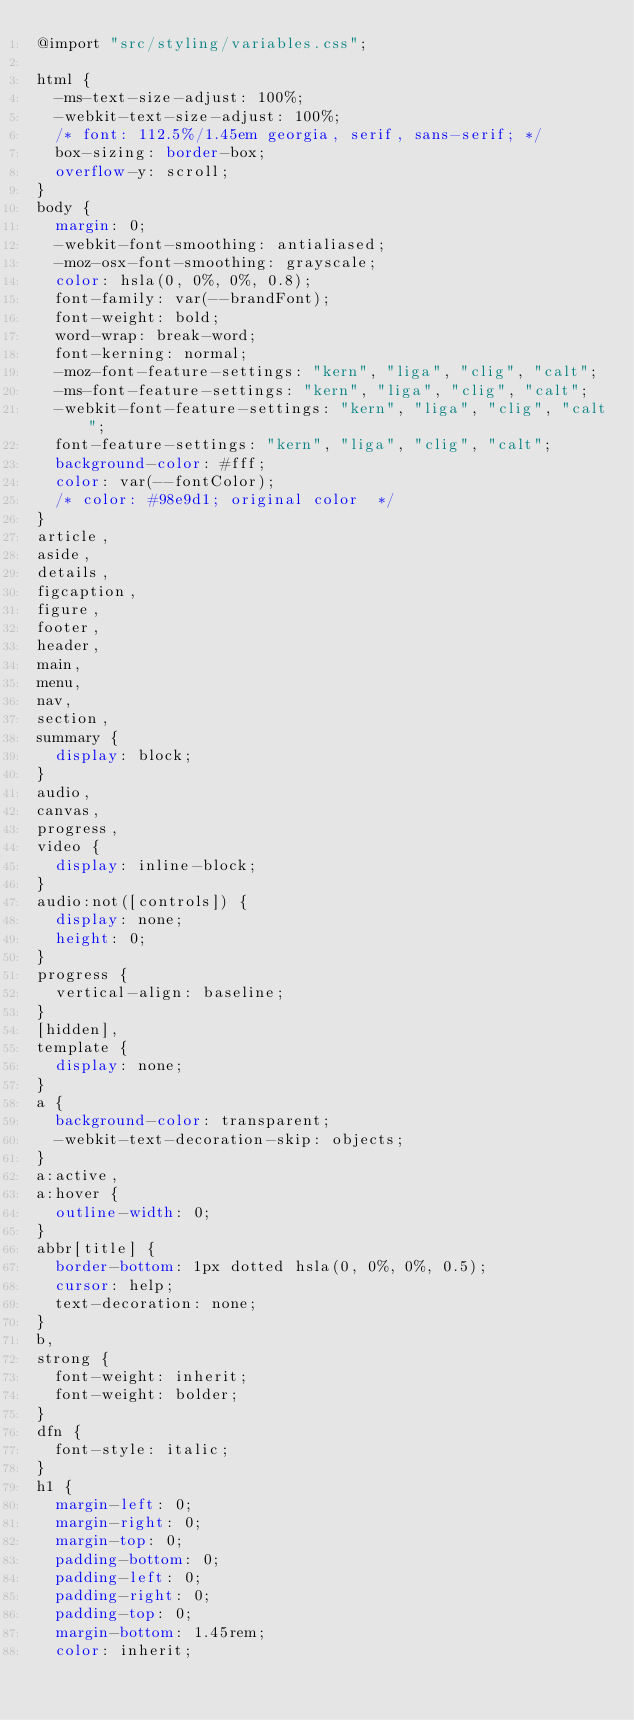Convert code to text. <code><loc_0><loc_0><loc_500><loc_500><_CSS_>@import "src/styling/variables.css";

html {
  -ms-text-size-adjust: 100%;
  -webkit-text-size-adjust: 100%;
  /* font: 112.5%/1.45em georgia, serif, sans-serif; */
  box-sizing: border-box;
  overflow-y: scroll;
}
body {
  margin: 0;
  -webkit-font-smoothing: antialiased;
  -moz-osx-font-smoothing: grayscale;
  color: hsla(0, 0%, 0%, 0.8);
  font-family: var(--brandFont);
  font-weight: bold;
  word-wrap: break-word;
  font-kerning: normal;
  -moz-font-feature-settings: "kern", "liga", "clig", "calt";
  -ms-font-feature-settings: "kern", "liga", "clig", "calt";
  -webkit-font-feature-settings: "kern", "liga", "clig", "calt";
  font-feature-settings: "kern", "liga", "clig", "calt";
  background-color: #fff;
  color: var(--fontColor);
  /* color: #98e9d1; original color  */
}
article,
aside,
details,
figcaption,
figure,
footer,
header,
main,
menu,
nav,
section,
summary {
  display: block;
}
audio,
canvas,
progress,
video {
  display: inline-block;
}
audio:not([controls]) {
  display: none;
  height: 0;
}
progress {
  vertical-align: baseline;
}
[hidden],
template {
  display: none;
}
a {
  background-color: transparent;
  -webkit-text-decoration-skip: objects;
}
a:active,
a:hover {
  outline-width: 0;
}
abbr[title] {
  border-bottom: 1px dotted hsla(0, 0%, 0%, 0.5);
  cursor: help;
  text-decoration: none;
}
b,
strong {
  font-weight: inherit;
  font-weight: bolder;
}
dfn {
  font-style: italic;
}
h1 {
  margin-left: 0;
  margin-right: 0;
  margin-top: 0;
  padding-bottom: 0;
  padding-left: 0;
  padding-right: 0;
  padding-top: 0;
  margin-bottom: 1.45rem;
  color: inherit;</code> 